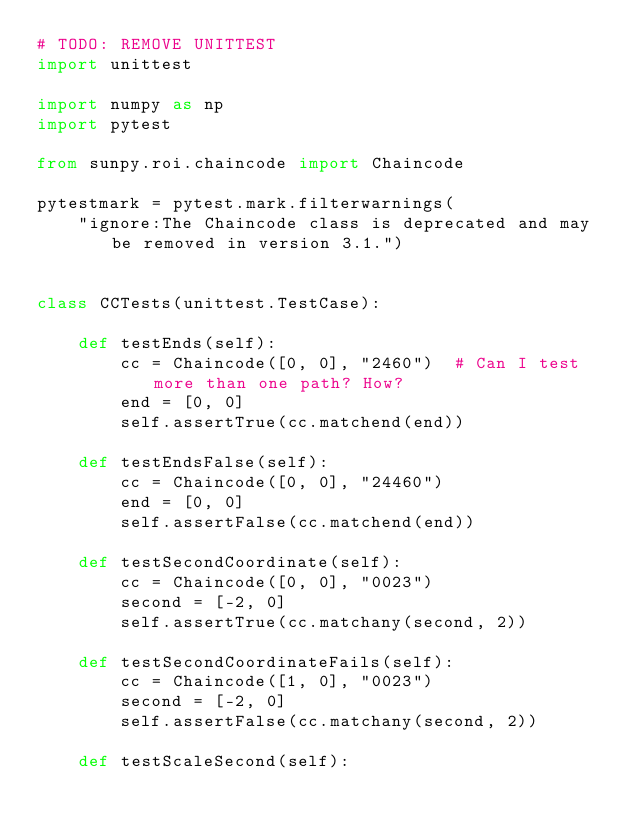Convert code to text. <code><loc_0><loc_0><loc_500><loc_500><_Python_># TODO: REMOVE UNITTEST
import unittest

import numpy as np
import pytest

from sunpy.roi.chaincode import Chaincode

pytestmark = pytest.mark.filterwarnings(
    "ignore:The Chaincode class is deprecated and may be removed in version 3.1.")


class CCTests(unittest.TestCase):

    def testEnds(self):
        cc = Chaincode([0, 0], "2460")  # Can I test more than one path? How?
        end = [0, 0]
        self.assertTrue(cc.matchend(end))

    def testEndsFalse(self):
        cc = Chaincode([0, 0], "24460")
        end = [0, 0]
        self.assertFalse(cc.matchend(end))

    def testSecondCoordinate(self):
        cc = Chaincode([0, 0], "0023")
        second = [-2, 0]
        self.assertTrue(cc.matchany(second, 2))

    def testSecondCoordinateFails(self):
        cc = Chaincode([1, 0], "0023")
        second = [-2, 0]
        self.assertFalse(cc.matchany(second, 2))

    def testScaleSecond(self):</code> 